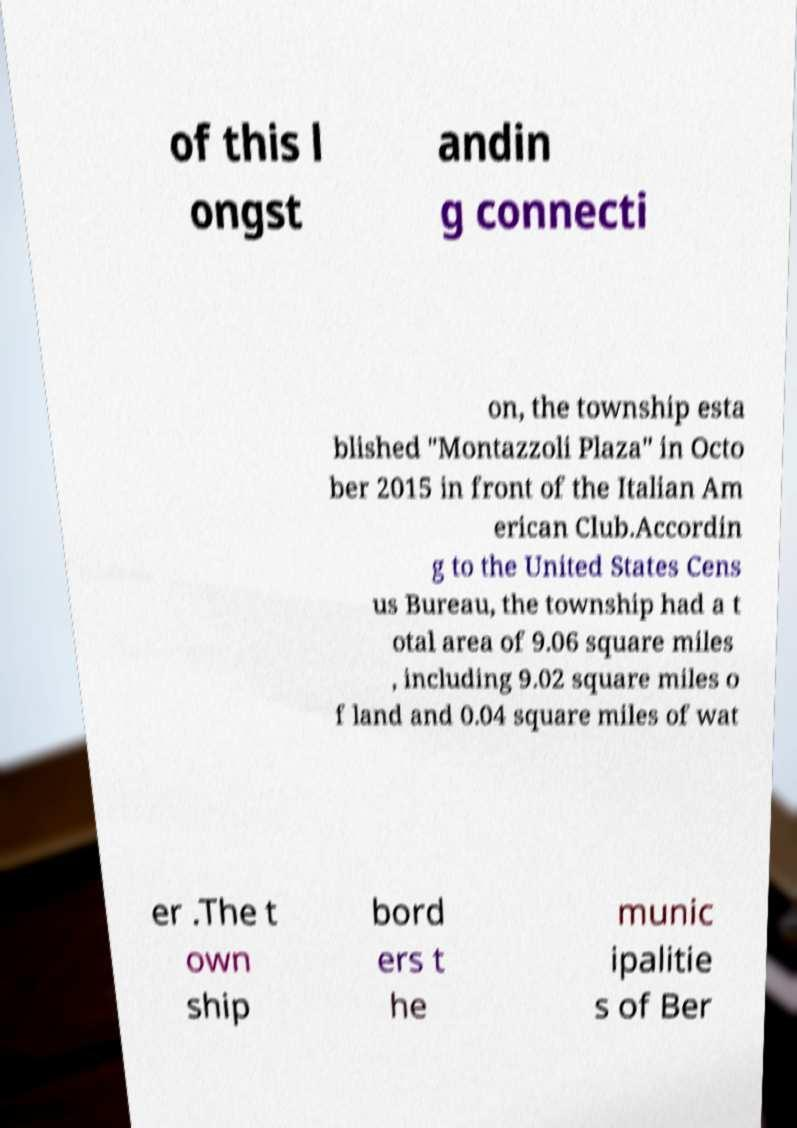Could you extract and type out the text from this image? of this l ongst andin g connecti on, the township esta blished "Montazzoli Plaza" in Octo ber 2015 in front of the Italian Am erican Club.Accordin g to the United States Cens us Bureau, the township had a t otal area of 9.06 square miles , including 9.02 square miles o f land and 0.04 square miles of wat er .The t own ship bord ers t he munic ipalitie s of Ber 